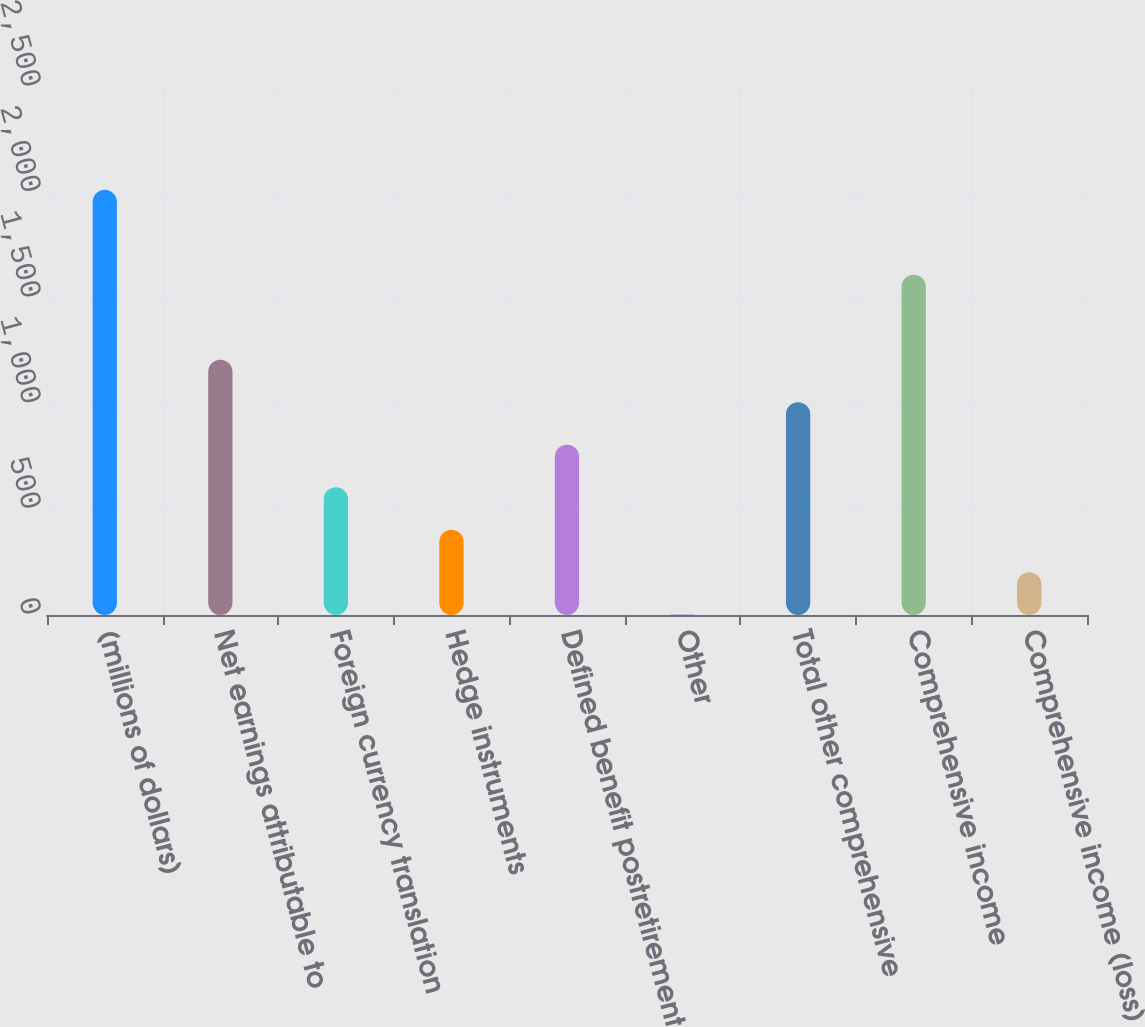Convert chart. <chart><loc_0><loc_0><loc_500><loc_500><bar_chart><fcel>(millions of dollars)<fcel>Net earnings attributable to<fcel>Foreign currency translation<fcel>Hedge instruments<fcel>Defined benefit postretirement<fcel>Other<fcel>Total other comprehensive<fcel>Comprehensive income<fcel>Comprehensive income (loss)<nl><fcel>2013<fcel>1208.4<fcel>604.95<fcel>403.8<fcel>806.1<fcel>1.5<fcel>1007.25<fcel>1610.7<fcel>202.65<nl></chart> 